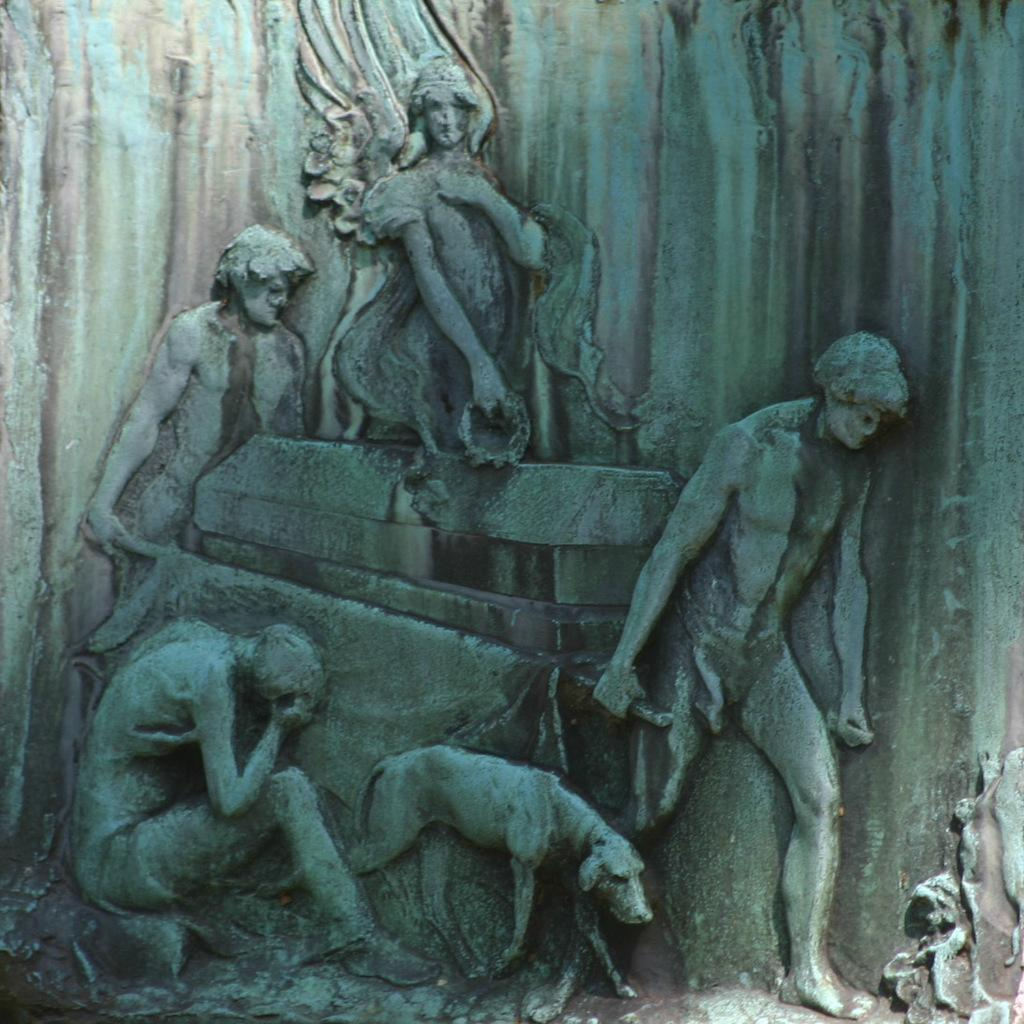What type of objects can be seen in the image? There are sculptures in the image. Where are the sculptures located? The sculptures are on a stone. What is the taste of the glass in the image? There is no glass present in the image, and therefore no taste can be determined. 